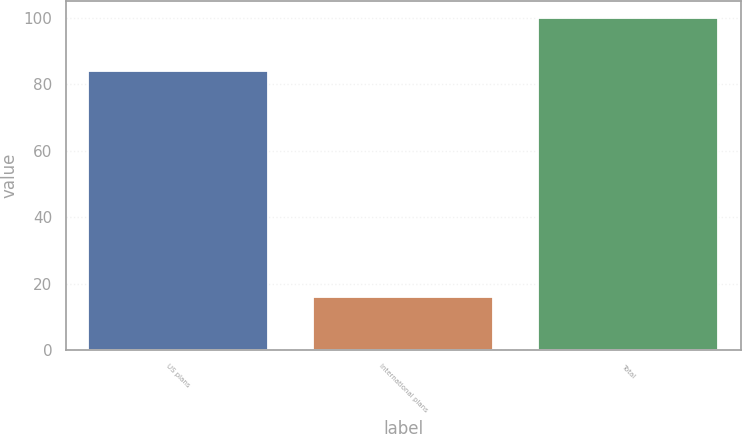<chart> <loc_0><loc_0><loc_500><loc_500><bar_chart><fcel>US plans<fcel>International plans<fcel>Total<nl><fcel>84<fcel>16<fcel>100<nl></chart> 